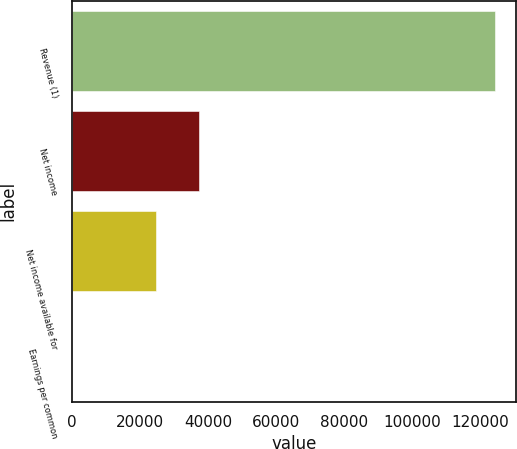Convert chart. <chart><loc_0><loc_0><loc_500><loc_500><bar_chart><fcel>Revenue (1)<fcel>Net income<fcel>Net income available for<fcel>Earnings per common<nl><fcel>124281<fcel>37284.6<fcel>24856.5<fcel>0.41<nl></chart> 